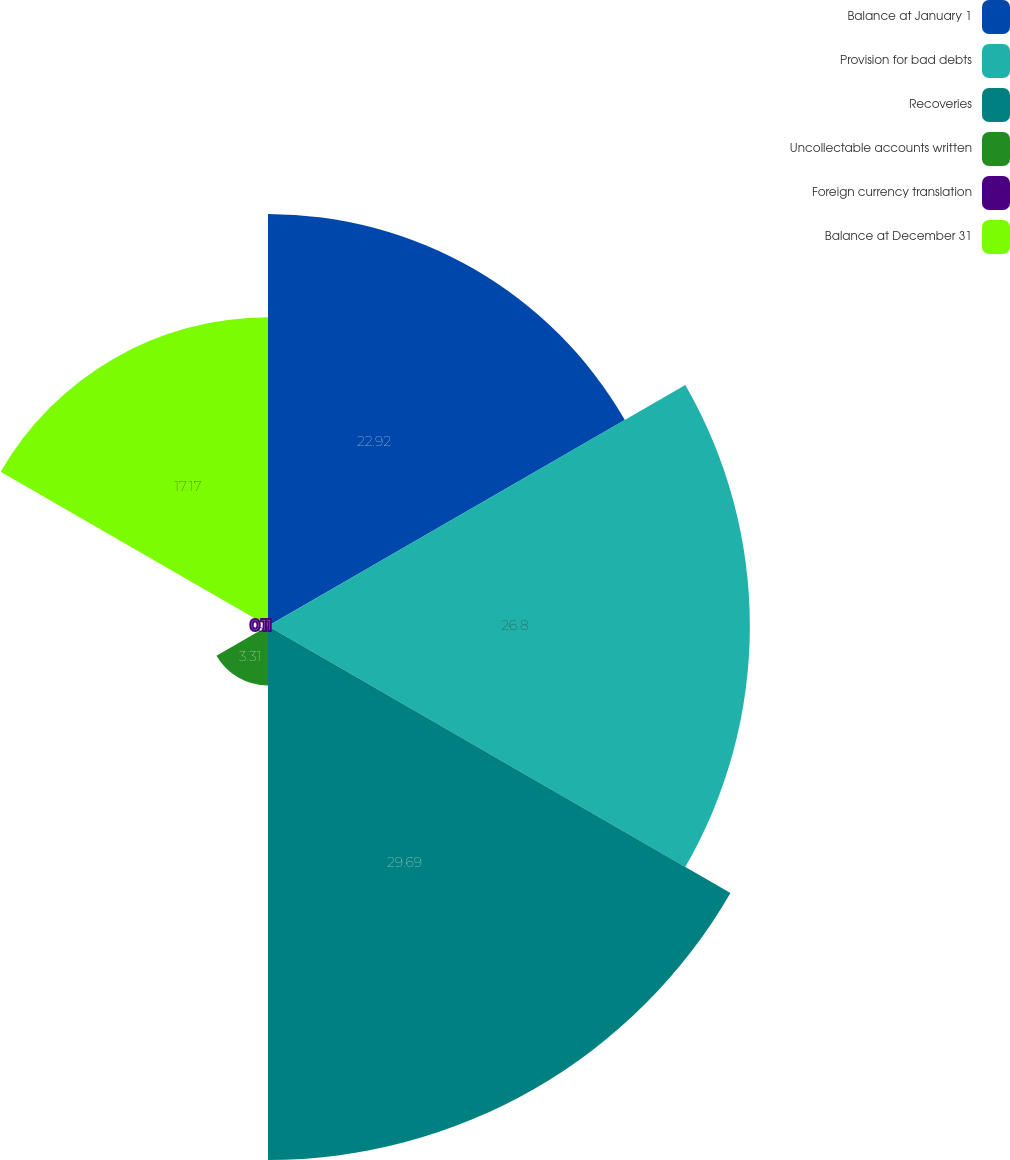Convert chart. <chart><loc_0><loc_0><loc_500><loc_500><pie_chart><fcel>Balance at January 1<fcel>Provision for bad debts<fcel>Recoveries<fcel>Uncollectable accounts written<fcel>Foreign currency translation<fcel>Balance at December 31<nl><fcel>22.92%<fcel>26.8%<fcel>29.7%<fcel>3.31%<fcel>0.11%<fcel>17.17%<nl></chart> 